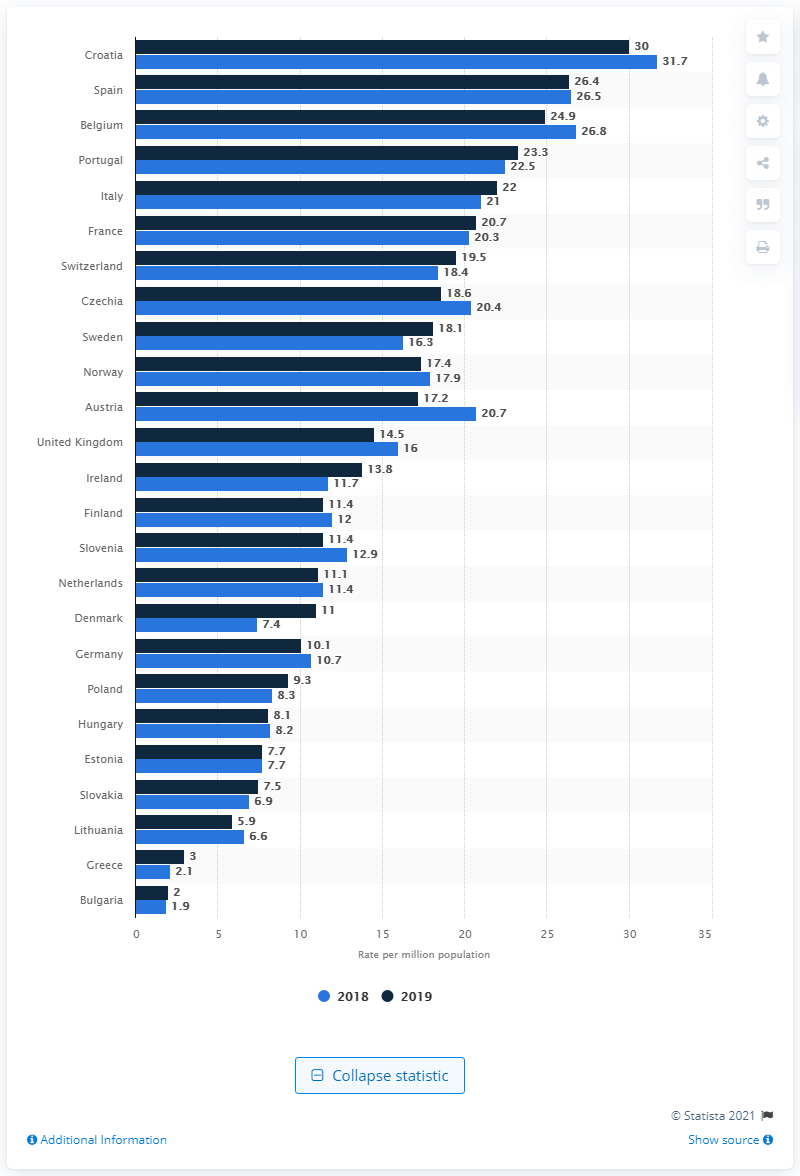Indicate a few pertinent items in this graphic. In 2018, Croatia's liver transplant rate was 31.7 per million population. Spain had the second highest rate of liver transplants in 2019. According to data from 2018 to 2019, Denmark had the largest increase in liver transplants among all countries. 